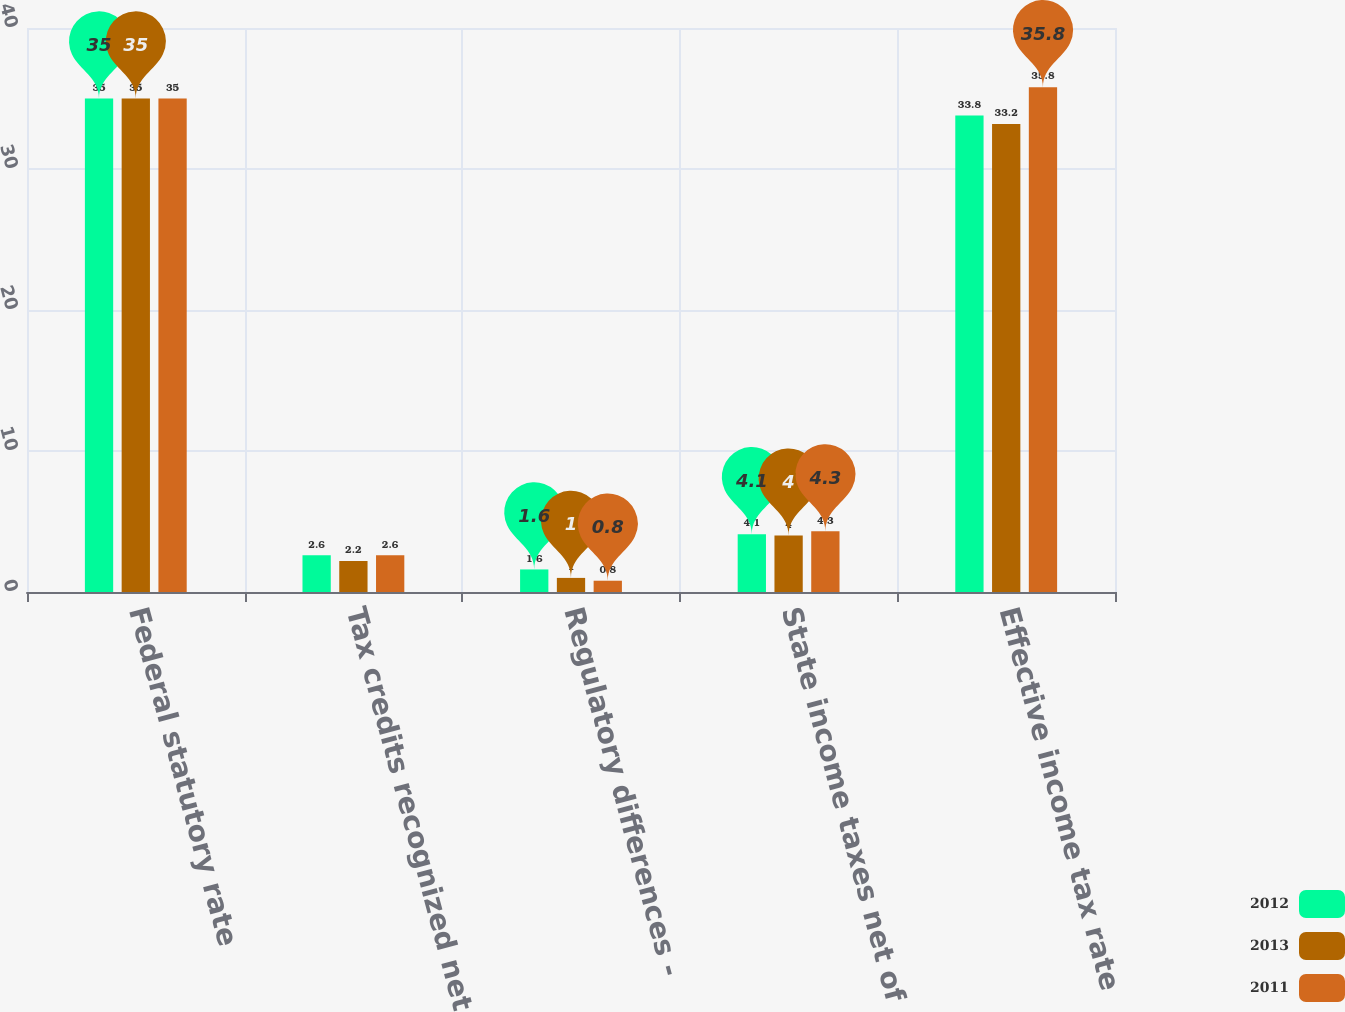Convert chart to OTSL. <chart><loc_0><loc_0><loc_500><loc_500><stacked_bar_chart><ecel><fcel>Federal statutory rate<fcel>Tax credits recognized net of<fcel>Regulatory differences -<fcel>State income taxes net of<fcel>Effective income tax rate<nl><fcel>2012<fcel>35<fcel>2.6<fcel>1.6<fcel>4.1<fcel>33.8<nl><fcel>2013<fcel>35<fcel>2.2<fcel>1<fcel>4<fcel>33.2<nl><fcel>2011<fcel>35<fcel>2.6<fcel>0.8<fcel>4.3<fcel>35.8<nl></chart> 